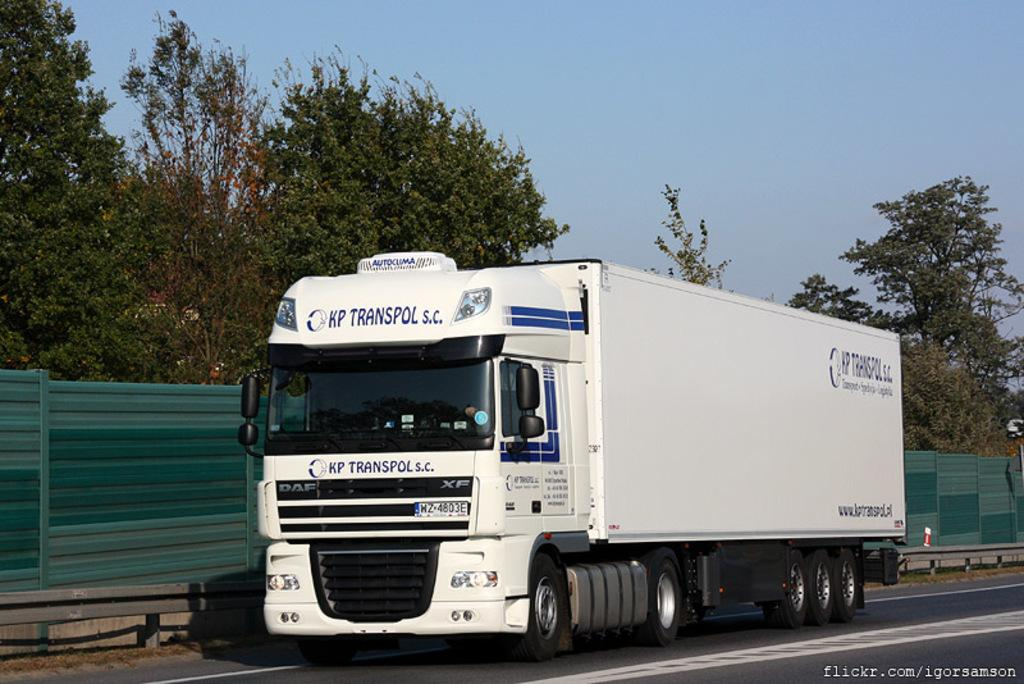What type of vegetation can be seen in the image? There are trees in the image. What is on the road in the image? There is a truck on the road. What safety feature is present beside the road? There is a safety barrier beside the road. What type of structure is beside the road? There is a metal wall beside the road. What is visible at the top of the image? The sky is visible at the top of the image. What type of feeling is expressed by the leaf in the image? There is no leaf present in the image, and therefore no feeling can be attributed to it. What advertisement can be seen on the metal wall beside the road? There is no advertisement visible on the metal wall in the image. 